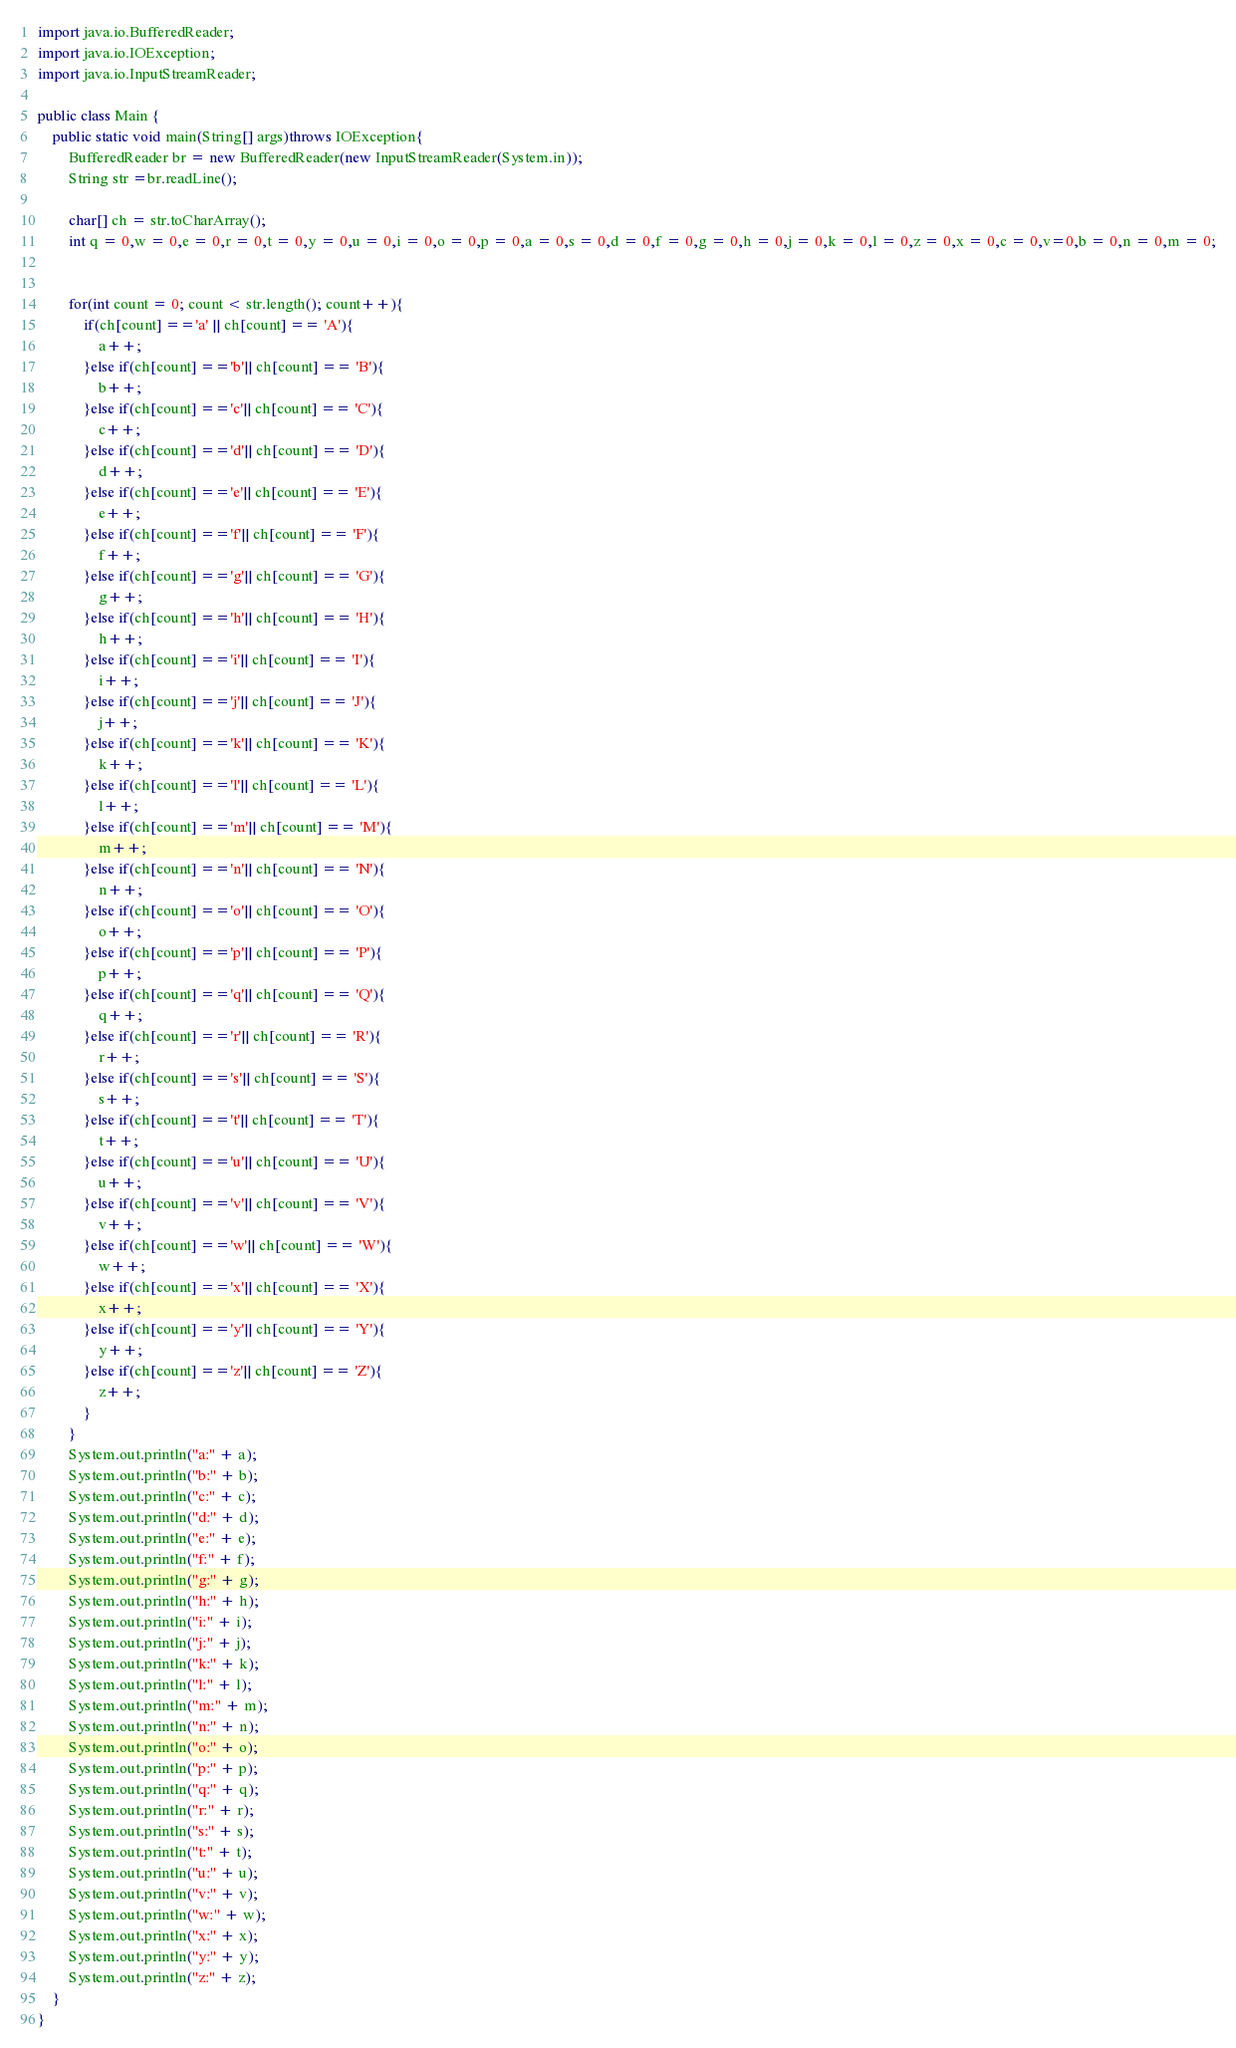<code> <loc_0><loc_0><loc_500><loc_500><_Java_>import java.io.BufferedReader;
import java.io.IOException;
import java.io.InputStreamReader;

public class Main {
	public static void main(String[] args)throws IOException{
		BufferedReader br = new BufferedReader(new InputStreamReader(System.in));
		String str =br.readLine();

		char[] ch = str.toCharArray();
		int q = 0,w = 0,e = 0,r = 0,t = 0,y = 0,u = 0,i = 0,o = 0,p = 0,a = 0,s = 0,d = 0,f = 0,g = 0,h = 0,j = 0,k = 0,l = 0,z = 0,x = 0,c = 0,v=0,b = 0,n = 0,m = 0;


		for(int count = 0; count < str.length(); count++){
			if(ch[count] =='a' || ch[count] == 'A'){
				a++;
			}else if(ch[count] =='b'|| ch[count] == 'B'){
				b++;
			}else if(ch[count] =='c'|| ch[count] == 'C'){
				c++;
			}else if(ch[count] =='d'|| ch[count] == 'D'){
				d++;
			}else if(ch[count] =='e'|| ch[count] == 'E'){
				e++;
			}else if(ch[count] =='f'|| ch[count] == 'F'){
				f++;
			}else if(ch[count] =='g'|| ch[count] == 'G'){
				g++;
			}else if(ch[count] =='h'|| ch[count] == 'H'){
				h++;
			}else if(ch[count] =='i'|| ch[count] == 'I'){
				i++;
			}else if(ch[count] =='j'|| ch[count] == 'J'){
				j++;
			}else if(ch[count] =='k'|| ch[count] == 'K'){
				k++;
			}else if(ch[count] =='l'|| ch[count] == 'L'){
				l++;
			}else if(ch[count] =='m'|| ch[count] == 'M'){
				m++;
			}else if(ch[count] =='n'|| ch[count] == 'N'){
				n++;
			}else if(ch[count] =='o'|| ch[count] == 'O'){
				o++;
			}else if(ch[count] =='p'|| ch[count] == 'P'){
				p++;
			}else if(ch[count] =='q'|| ch[count] == 'Q'){
				q++;
			}else if(ch[count] =='r'|| ch[count] == 'R'){
				r++;
			}else if(ch[count] =='s'|| ch[count] == 'S'){
				s++;
			}else if(ch[count] =='t'|| ch[count] == 'T'){
				t++;
			}else if(ch[count] =='u'|| ch[count] == 'U'){
				u++;
			}else if(ch[count] =='v'|| ch[count] == 'V'){
				v++;
			}else if(ch[count] =='w'|| ch[count] == 'W'){
				w++;
			}else if(ch[count] =='x'|| ch[count] == 'X'){
				x++;
			}else if(ch[count] =='y'|| ch[count] == 'Y'){
				y++;
			}else if(ch[count] =='z'|| ch[count] == 'Z'){
				z++;
			}
		}
		System.out.println("a:" + a);
		System.out.println("b:" + b);
		System.out.println("c:" + c);
		System.out.println("d:" + d);
		System.out.println("e:" + e);
		System.out.println("f:" + f);
		System.out.println("g:" + g);
		System.out.println("h:" + h);
		System.out.println("i:" + i);
		System.out.println("j:" + j);
		System.out.println("k:" + k);
		System.out.println("l:" + l);
		System.out.println("m:" + m);
		System.out.println("n:" + n);
		System.out.println("o:" + o);
		System.out.println("p:" + p);
		System.out.println("q:" + q);
		System.out.println("r:" + r);
		System.out.println("s:" + s);
		System.out.println("t:" + t);
		System.out.println("u:" + u);
		System.out.println("v:" + v);
		System.out.println("w:" + w);
		System.out.println("x:" + x);
		System.out.println("y:" + y);
		System.out.println("z:" + z);
	}
}</code> 